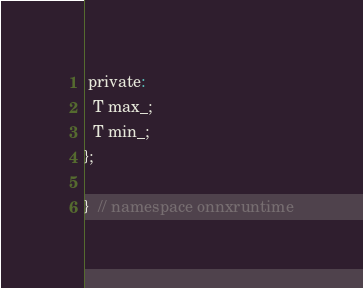Convert code to text. <code><loc_0><loc_0><loc_500><loc_500><_C_>
 private:
  T max_;
  T min_;
};

}  // namespace onnxruntime
</code> 